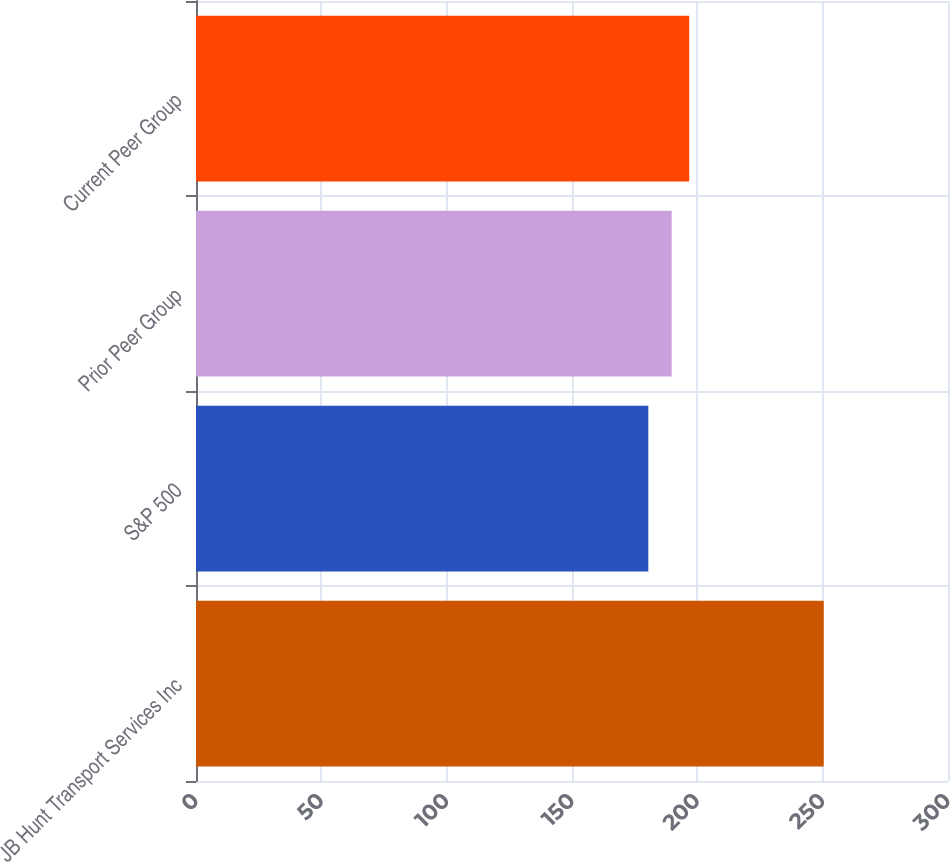Convert chart to OTSL. <chart><loc_0><loc_0><loc_500><loc_500><bar_chart><fcel>JB Hunt Transport Services Inc<fcel>S&P 500<fcel>Prior Peer Group<fcel>Current Peer Group<nl><fcel>250.42<fcel>180.44<fcel>189.76<fcel>196.76<nl></chart> 